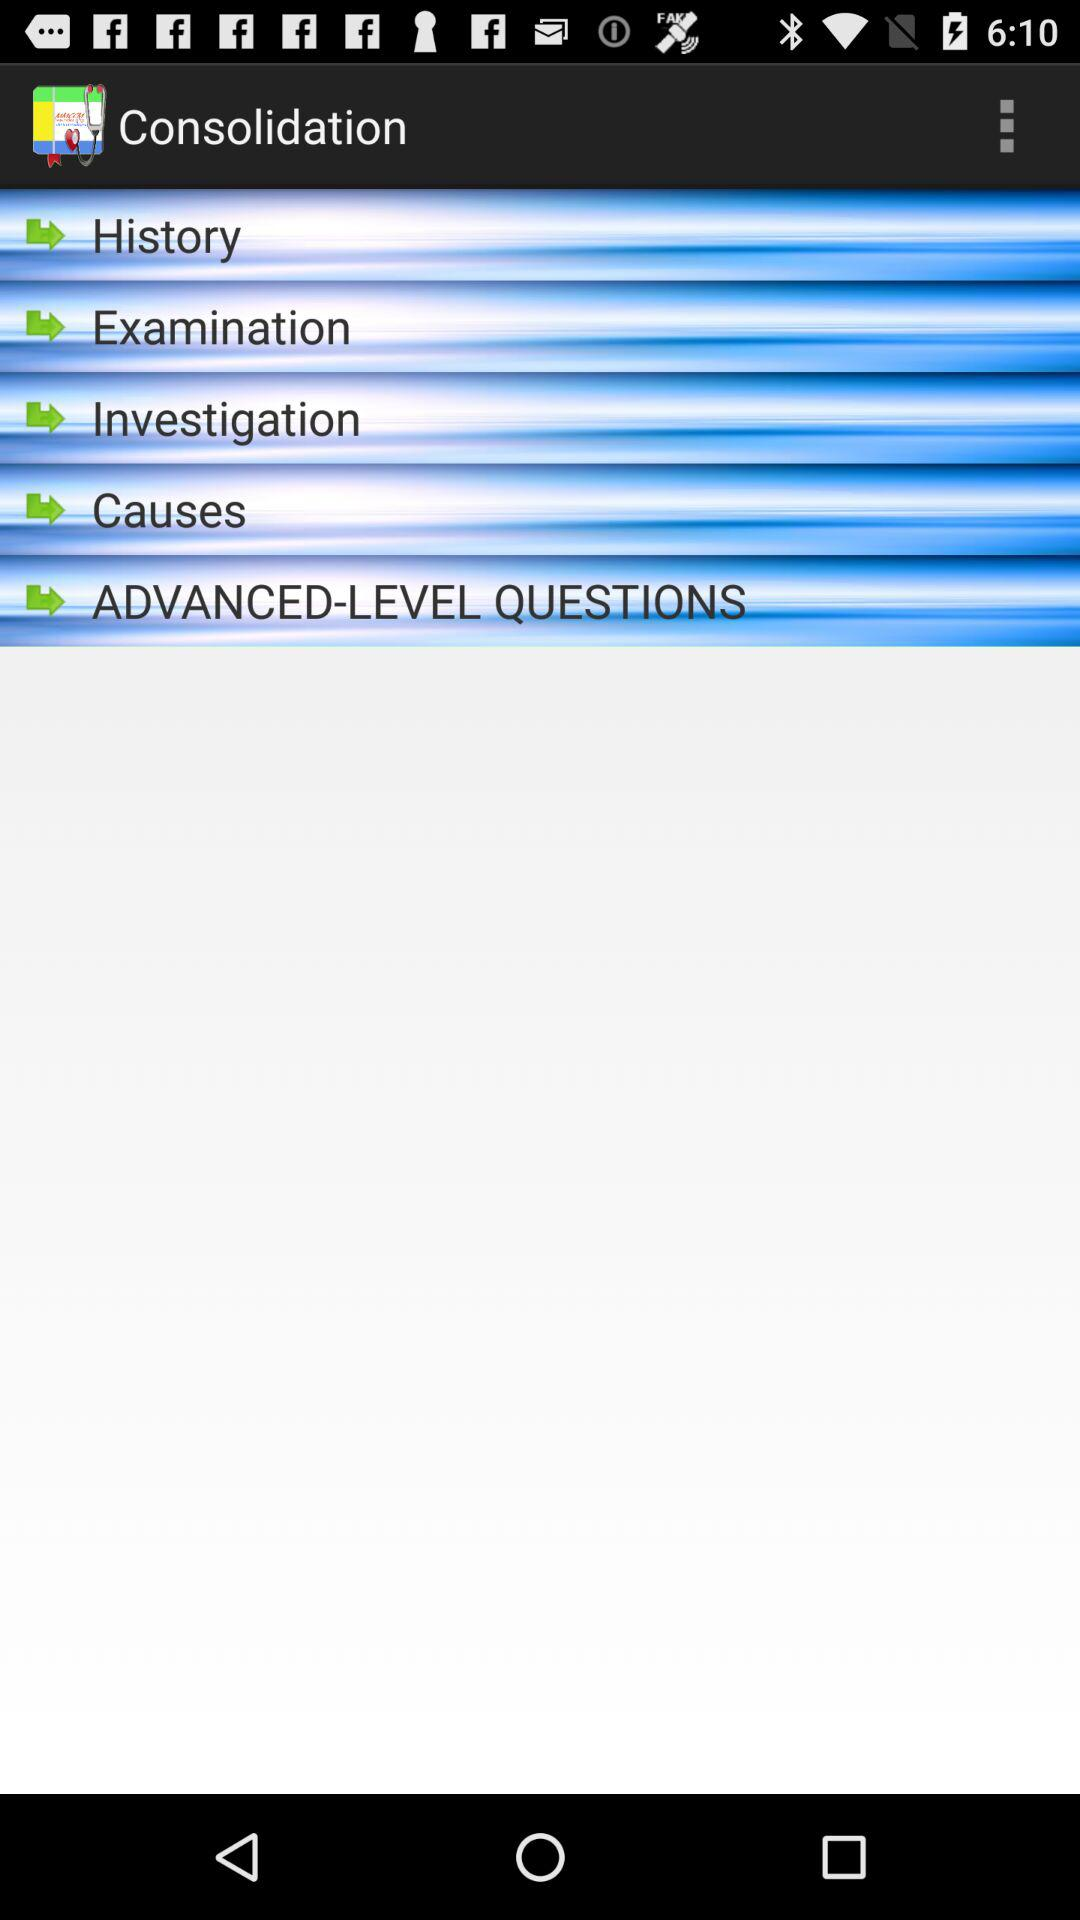What is the application name? The application name is "Consolidation". 